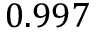<formula> <loc_0><loc_0><loc_500><loc_500>0 . 9 9 7</formula> 